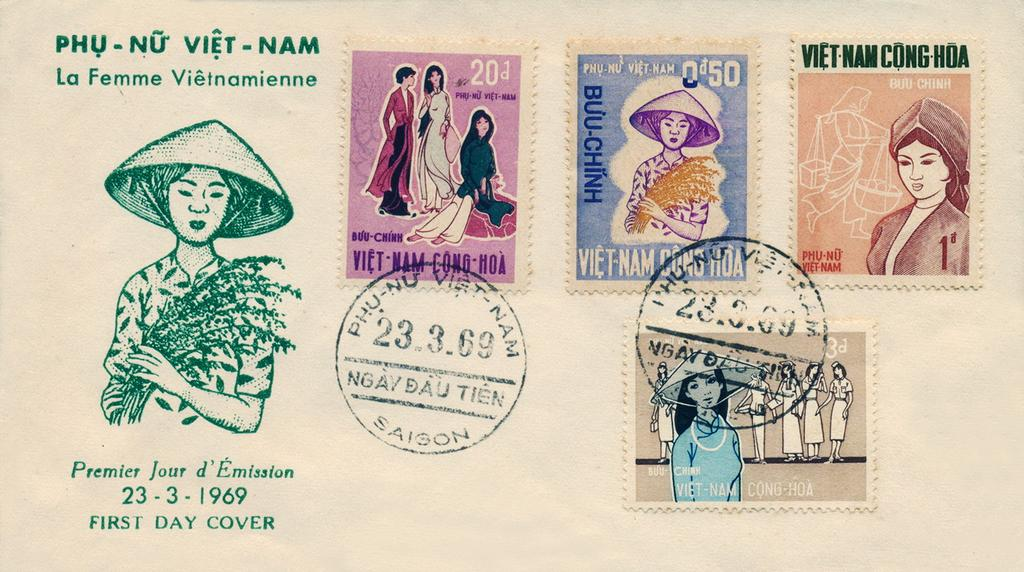What is the main subject of the image? The main subject of the image is postage stamps on a cream-colored surface. Are there any other elements in the image besides the postage stamps? Yes, there is an art piece of a person and additional stamps in the image. Is there any text present in the image? Yes, there is text written on the image. Reasoning: Let's think step by step by step in order to produce the conversation. We start by identifying the main subject of the image, which is the postage stamps on a cream-colored surface. Then, we expand the conversation to include other elements that are also visible, such as the art piece of a person and additional stamps. Finally, we mention the presence of text in the image. Absurd Question/Answer: How many babies are holding onto the sock in the image? There are no babies or socks present in the image. How many babies are holding onto the sock in the image? There are no babies or socks present in the image. 